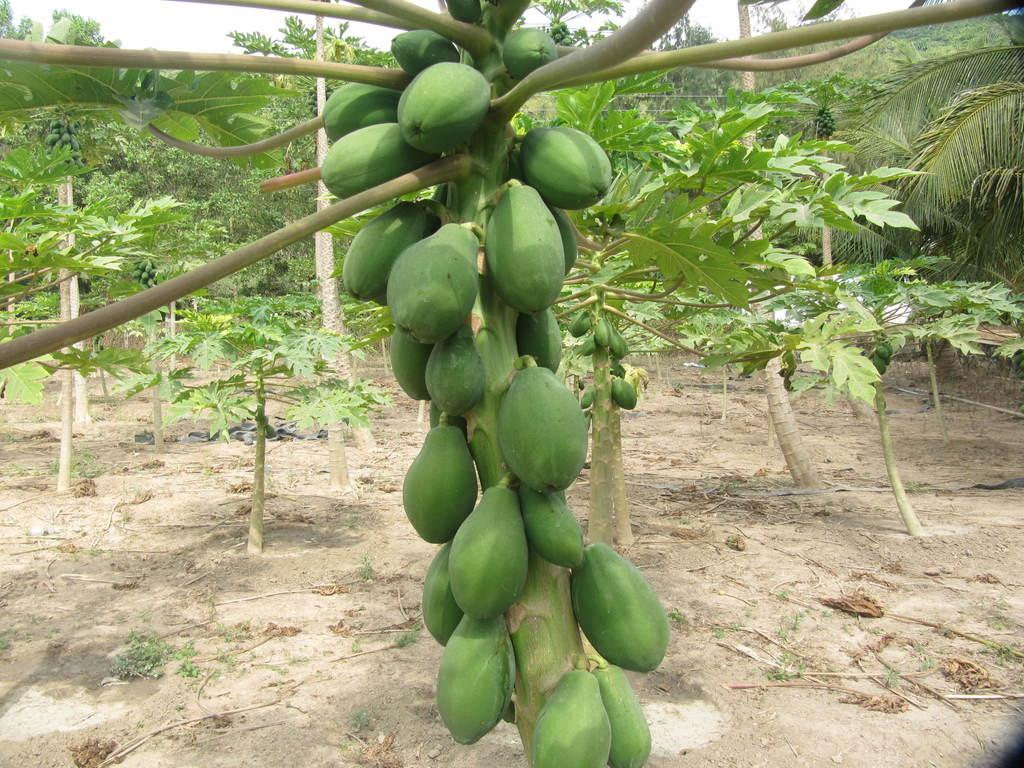What type of trees can be seen in the image? There are papaya trees in the image. What is the color of the papayas on the trees? The papayas on the trees are green in color. What part of the natural environment is visible in the image? There is a part of the sky visible in the image. What type of suit is the kitty wearing in the image? There is no kitty or suit present in the image. 